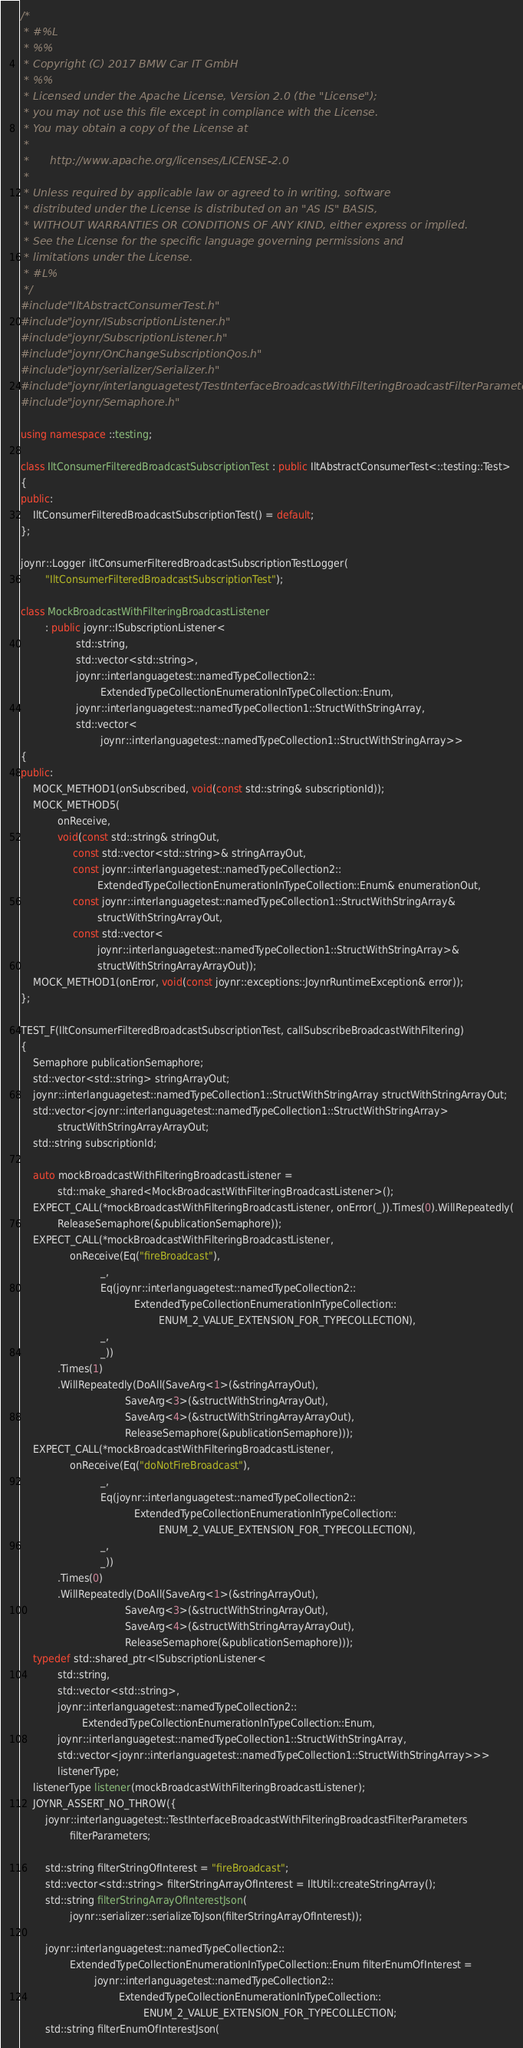<code> <loc_0><loc_0><loc_500><loc_500><_C++_>/*
 * #%L
 * %%
 * Copyright (C) 2017 BMW Car IT GmbH
 * %%
 * Licensed under the Apache License, Version 2.0 (the "License");
 * you may not use this file except in compliance with the License.
 * You may obtain a copy of the License at
 * 
 *      http://www.apache.org/licenses/LICENSE-2.0
 * 
 * Unless required by applicable law or agreed to in writing, software
 * distributed under the License is distributed on an "AS IS" BASIS,
 * WITHOUT WARRANTIES OR CONDITIONS OF ANY KIND, either express or implied.
 * See the License for the specific language governing permissions and
 * limitations under the License.
 * #L%
 */
#include "IltAbstractConsumerTest.h"
#include "joynr/ISubscriptionListener.h"
#include "joynr/SubscriptionListener.h"
#include "joynr/OnChangeSubscriptionQos.h"
#include "joynr/serializer/Serializer.h"
#include "joynr/interlanguagetest/TestInterfaceBroadcastWithFilteringBroadcastFilterParameters.h"
#include "joynr/Semaphore.h"

using namespace ::testing;

class IltConsumerFilteredBroadcastSubscriptionTest : public IltAbstractConsumerTest<::testing::Test>
{
public:
    IltConsumerFilteredBroadcastSubscriptionTest() = default;
};

joynr::Logger iltConsumerFilteredBroadcastSubscriptionTestLogger(
        "IltConsumerFilteredBroadcastSubscriptionTest");

class MockBroadcastWithFilteringBroadcastListener
        : public joynr::ISubscriptionListener<
                  std::string,
                  std::vector<std::string>,
                  joynr::interlanguagetest::namedTypeCollection2::
                          ExtendedTypeCollectionEnumerationInTypeCollection::Enum,
                  joynr::interlanguagetest::namedTypeCollection1::StructWithStringArray,
                  std::vector<
                          joynr::interlanguagetest::namedTypeCollection1::StructWithStringArray>>
{
public:
    MOCK_METHOD1(onSubscribed, void(const std::string& subscriptionId));
    MOCK_METHOD5(
            onReceive,
            void(const std::string& stringOut,
                 const std::vector<std::string>& stringArrayOut,
                 const joynr::interlanguagetest::namedTypeCollection2::
                         ExtendedTypeCollectionEnumerationInTypeCollection::Enum& enumerationOut,
                 const joynr::interlanguagetest::namedTypeCollection1::StructWithStringArray&
                         structWithStringArrayOut,
                 const std::vector<
                         joynr::interlanguagetest::namedTypeCollection1::StructWithStringArray>&
                         structWithStringArrayArrayOut));
    MOCK_METHOD1(onError, void(const joynr::exceptions::JoynrRuntimeException& error));
};

TEST_F(IltConsumerFilteredBroadcastSubscriptionTest, callSubscribeBroadcastWithFiltering)
{
    Semaphore publicationSemaphore;
    std::vector<std::string> stringArrayOut;
    joynr::interlanguagetest::namedTypeCollection1::StructWithStringArray structWithStringArrayOut;
    std::vector<joynr::interlanguagetest::namedTypeCollection1::StructWithStringArray>
            structWithStringArrayArrayOut;
    std::string subscriptionId;

    auto mockBroadcastWithFilteringBroadcastListener =
            std::make_shared<MockBroadcastWithFilteringBroadcastListener>();
    EXPECT_CALL(*mockBroadcastWithFilteringBroadcastListener, onError(_)).Times(0).WillRepeatedly(
            ReleaseSemaphore(&publicationSemaphore));
    EXPECT_CALL(*mockBroadcastWithFilteringBroadcastListener,
                onReceive(Eq("fireBroadcast"),
                          _,
                          Eq(joynr::interlanguagetest::namedTypeCollection2::
                                     ExtendedTypeCollectionEnumerationInTypeCollection::
                                             ENUM_2_VALUE_EXTENSION_FOR_TYPECOLLECTION),
                          _,
                          _))
            .Times(1)
            .WillRepeatedly(DoAll(SaveArg<1>(&stringArrayOut),
                                  SaveArg<3>(&structWithStringArrayOut),
                                  SaveArg<4>(&structWithStringArrayArrayOut),
                                  ReleaseSemaphore(&publicationSemaphore)));
    EXPECT_CALL(*mockBroadcastWithFilteringBroadcastListener,
                onReceive(Eq("doNotFireBroadcast"),
                          _,
                          Eq(joynr::interlanguagetest::namedTypeCollection2::
                                     ExtendedTypeCollectionEnumerationInTypeCollection::
                                             ENUM_2_VALUE_EXTENSION_FOR_TYPECOLLECTION),
                          _,
                          _))
            .Times(0)
            .WillRepeatedly(DoAll(SaveArg<1>(&stringArrayOut),
                                  SaveArg<3>(&structWithStringArrayOut),
                                  SaveArg<4>(&structWithStringArrayArrayOut),
                                  ReleaseSemaphore(&publicationSemaphore)));
    typedef std::shared_ptr<ISubscriptionListener<
            std::string,
            std::vector<std::string>,
            joynr::interlanguagetest::namedTypeCollection2::
                    ExtendedTypeCollectionEnumerationInTypeCollection::Enum,
            joynr::interlanguagetest::namedTypeCollection1::StructWithStringArray,
            std::vector<joynr::interlanguagetest::namedTypeCollection1::StructWithStringArray>>>
            listenerType;
    listenerType listener(mockBroadcastWithFilteringBroadcastListener);
    JOYNR_ASSERT_NO_THROW({
        joynr::interlanguagetest::TestInterfaceBroadcastWithFilteringBroadcastFilterParameters
                filterParameters;

        std::string filterStringOfInterest = "fireBroadcast";
        std::vector<std::string> filterStringArrayOfInterest = IltUtil::createStringArray();
        std::string filterStringArrayOfInterestJson(
                joynr::serializer::serializeToJson(filterStringArrayOfInterest));

        joynr::interlanguagetest::namedTypeCollection2::
                ExtendedTypeCollectionEnumerationInTypeCollection::Enum filterEnumOfInterest =
                        joynr::interlanguagetest::namedTypeCollection2::
                                ExtendedTypeCollectionEnumerationInTypeCollection::
                                        ENUM_2_VALUE_EXTENSION_FOR_TYPECOLLECTION;
        std::string filterEnumOfInterestJson(</code> 